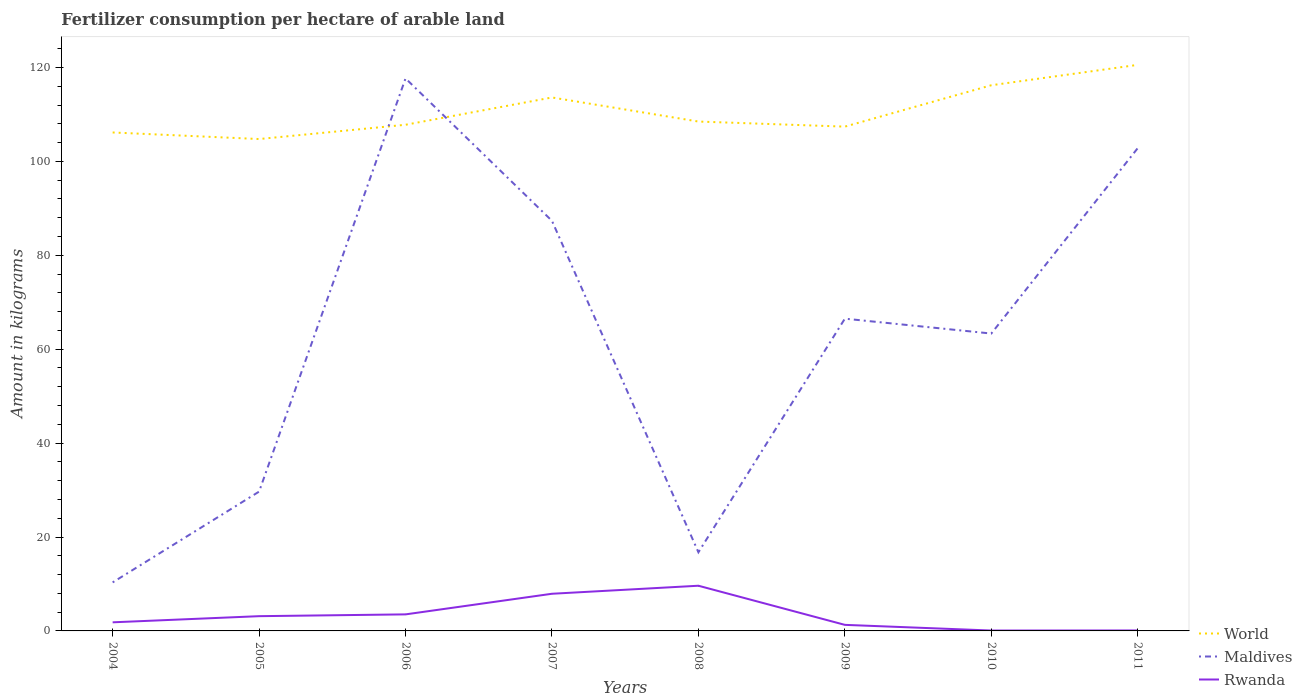Does the line corresponding to World intersect with the line corresponding to Maldives?
Your response must be concise. Yes. Is the number of lines equal to the number of legend labels?
Provide a short and direct response. Yes. Across all years, what is the maximum amount of fertilizer consumption in Rwanda?
Your answer should be compact. 0.08. In which year was the amount of fertilizer consumption in Rwanda maximum?
Provide a short and direct response. 2010. What is the total amount of fertilizer consumption in Rwanda in the graph?
Your answer should be very brief. -1.71. What is the difference between the highest and the second highest amount of fertilizer consumption in Maldives?
Provide a short and direct response. 107.33. Is the amount of fertilizer consumption in World strictly greater than the amount of fertilizer consumption in Maldives over the years?
Give a very brief answer. No. How many lines are there?
Give a very brief answer. 3. Does the graph contain any zero values?
Ensure brevity in your answer.  No. Does the graph contain grids?
Your answer should be very brief. No. Where does the legend appear in the graph?
Ensure brevity in your answer.  Bottom right. How many legend labels are there?
Provide a short and direct response. 3. What is the title of the graph?
Keep it short and to the point. Fertilizer consumption per hectare of arable land. What is the label or title of the X-axis?
Your response must be concise. Years. What is the label or title of the Y-axis?
Your answer should be compact. Amount in kilograms. What is the Amount in kilograms in World in 2004?
Ensure brevity in your answer.  106.15. What is the Amount in kilograms in Maldives in 2004?
Your answer should be very brief. 10.33. What is the Amount in kilograms of Rwanda in 2004?
Offer a terse response. 1.83. What is the Amount in kilograms of World in 2005?
Your answer should be compact. 104.76. What is the Amount in kilograms of Maldives in 2005?
Your response must be concise. 29.67. What is the Amount in kilograms of Rwanda in 2005?
Offer a terse response. 3.14. What is the Amount in kilograms of World in 2006?
Offer a very short reply. 107.79. What is the Amount in kilograms of Maldives in 2006?
Offer a terse response. 117.67. What is the Amount in kilograms of Rwanda in 2006?
Your response must be concise. 3.52. What is the Amount in kilograms in World in 2007?
Give a very brief answer. 113.61. What is the Amount in kilograms of Maldives in 2007?
Ensure brevity in your answer.  87.33. What is the Amount in kilograms in Rwanda in 2007?
Make the answer very short. 7.91. What is the Amount in kilograms of World in 2008?
Provide a short and direct response. 108.48. What is the Amount in kilograms in Maldives in 2008?
Your answer should be very brief. 16.75. What is the Amount in kilograms of Rwanda in 2008?
Your answer should be very brief. 9.62. What is the Amount in kilograms of World in 2009?
Provide a short and direct response. 107.4. What is the Amount in kilograms in Maldives in 2009?
Offer a very short reply. 66.5. What is the Amount in kilograms of Rwanda in 2009?
Your response must be concise. 1.29. What is the Amount in kilograms of World in 2010?
Make the answer very short. 116.21. What is the Amount in kilograms of Maldives in 2010?
Offer a terse response. 63.33. What is the Amount in kilograms in Rwanda in 2010?
Ensure brevity in your answer.  0.08. What is the Amount in kilograms of World in 2011?
Provide a succinct answer. 120.55. What is the Amount in kilograms in Maldives in 2011?
Your answer should be compact. 102.82. What is the Amount in kilograms in Rwanda in 2011?
Your answer should be very brief. 0.1. Across all years, what is the maximum Amount in kilograms in World?
Your response must be concise. 120.55. Across all years, what is the maximum Amount in kilograms of Maldives?
Offer a very short reply. 117.67. Across all years, what is the maximum Amount in kilograms in Rwanda?
Provide a short and direct response. 9.62. Across all years, what is the minimum Amount in kilograms of World?
Provide a succinct answer. 104.76. Across all years, what is the minimum Amount in kilograms of Maldives?
Give a very brief answer. 10.33. Across all years, what is the minimum Amount in kilograms in Rwanda?
Offer a very short reply. 0.08. What is the total Amount in kilograms of World in the graph?
Make the answer very short. 884.96. What is the total Amount in kilograms of Maldives in the graph?
Provide a succinct answer. 494.4. What is the total Amount in kilograms of Rwanda in the graph?
Give a very brief answer. 27.51. What is the difference between the Amount in kilograms in World in 2004 and that in 2005?
Your answer should be very brief. 1.4. What is the difference between the Amount in kilograms of Maldives in 2004 and that in 2005?
Give a very brief answer. -19.33. What is the difference between the Amount in kilograms in Rwanda in 2004 and that in 2005?
Keep it short and to the point. -1.31. What is the difference between the Amount in kilograms of World in 2004 and that in 2006?
Your answer should be compact. -1.64. What is the difference between the Amount in kilograms of Maldives in 2004 and that in 2006?
Your answer should be compact. -107.33. What is the difference between the Amount in kilograms of Rwanda in 2004 and that in 2006?
Provide a succinct answer. -1.69. What is the difference between the Amount in kilograms in World in 2004 and that in 2007?
Keep it short and to the point. -7.45. What is the difference between the Amount in kilograms of Maldives in 2004 and that in 2007?
Provide a succinct answer. -77. What is the difference between the Amount in kilograms in Rwanda in 2004 and that in 2007?
Give a very brief answer. -6.08. What is the difference between the Amount in kilograms of World in 2004 and that in 2008?
Offer a terse response. -2.33. What is the difference between the Amount in kilograms in Maldives in 2004 and that in 2008?
Provide a short and direct response. -6.42. What is the difference between the Amount in kilograms of Rwanda in 2004 and that in 2008?
Keep it short and to the point. -7.79. What is the difference between the Amount in kilograms of World in 2004 and that in 2009?
Your response must be concise. -1.24. What is the difference between the Amount in kilograms in Maldives in 2004 and that in 2009?
Make the answer very short. -56.17. What is the difference between the Amount in kilograms in Rwanda in 2004 and that in 2009?
Your answer should be compact. 0.54. What is the difference between the Amount in kilograms in World in 2004 and that in 2010?
Offer a terse response. -10.06. What is the difference between the Amount in kilograms of Maldives in 2004 and that in 2010?
Your answer should be compact. -53. What is the difference between the Amount in kilograms of Rwanda in 2004 and that in 2010?
Offer a very short reply. 1.75. What is the difference between the Amount in kilograms of World in 2004 and that in 2011?
Provide a succinct answer. -14.4. What is the difference between the Amount in kilograms of Maldives in 2004 and that in 2011?
Make the answer very short. -92.49. What is the difference between the Amount in kilograms of Rwanda in 2004 and that in 2011?
Provide a short and direct response. 1.73. What is the difference between the Amount in kilograms in World in 2005 and that in 2006?
Provide a succinct answer. -3.04. What is the difference between the Amount in kilograms in Maldives in 2005 and that in 2006?
Your answer should be compact. -88. What is the difference between the Amount in kilograms in Rwanda in 2005 and that in 2006?
Make the answer very short. -0.38. What is the difference between the Amount in kilograms of World in 2005 and that in 2007?
Make the answer very short. -8.85. What is the difference between the Amount in kilograms in Maldives in 2005 and that in 2007?
Provide a short and direct response. -57.67. What is the difference between the Amount in kilograms in Rwanda in 2005 and that in 2007?
Offer a terse response. -4.78. What is the difference between the Amount in kilograms of World in 2005 and that in 2008?
Provide a short and direct response. -3.73. What is the difference between the Amount in kilograms of Maldives in 2005 and that in 2008?
Give a very brief answer. 12.92. What is the difference between the Amount in kilograms in Rwanda in 2005 and that in 2008?
Provide a short and direct response. -6.48. What is the difference between the Amount in kilograms in World in 2005 and that in 2009?
Offer a very short reply. -2.64. What is the difference between the Amount in kilograms in Maldives in 2005 and that in 2009?
Ensure brevity in your answer.  -36.83. What is the difference between the Amount in kilograms in Rwanda in 2005 and that in 2009?
Your response must be concise. 1.85. What is the difference between the Amount in kilograms in World in 2005 and that in 2010?
Give a very brief answer. -11.46. What is the difference between the Amount in kilograms of Maldives in 2005 and that in 2010?
Offer a very short reply. -33.67. What is the difference between the Amount in kilograms in Rwanda in 2005 and that in 2010?
Your response must be concise. 3.06. What is the difference between the Amount in kilograms of World in 2005 and that in 2011?
Your response must be concise. -15.8. What is the difference between the Amount in kilograms of Maldives in 2005 and that in 2011?
Your answer should be compact. -73.15. What is the difference between the Amount in kilograms of Rwanda in 2005 and that in 2011?
Provide a succinct answer. 3.04. What is the difference between the Amount in kilograms of World in 2006 and that in 2007?
Make the answer very short. -5.81. What is the difference between the Amount in kilograms of Maldives in 2006 and that in 2007?
Ensure brevity in your answer.  30.33. What is the difference between the Amount in kilograms of Rwanda in 2006 and that in 2007?
Provide a succinct answer. -4.39. What is the difference between the Amount in kilograms in World in 2006 and that in 2008?
Offer a very short reply. -0.69. What is the difference between the Amount in kilograms of Maldives in 2006 and that in 2008?
Your answer should be very brief. 100.92. What is the difference between the Amount in kilograms of Rwanda in 2006 and that in 2008?
Make the answer very short. -6.1. What is the difference between the Amount in kilograms of World in 2006 and that in 2009?
Your response must be concise. 0.4. What is the difference between the Amount in kilograms in Maldives in 2006 and that in 2009?
Provide a succinct answer. 51.17. What is the difference between the Amount in kilograms in Rwanda in 2006 and that in 2009?
Your answer should be very brief. 2.23. What is the difference between the Amount in kilograms of World in 2006 and that in 2010?
Keep it short and to the point. -8.42. What is the difference between the Amount in kilograms of Maldives in 2006 and that in 2010?
Provide a succinct answer. 54.33. What is the difference between the Amount in kilograms in Rwanda in 2006 and that in 2010?
Keep it short and to the point. 3.44. What is the difference between the Amount in kilograms of World in 2006 and that in 2011?
Make the answer very short. -12.76. What is the difference between the Amount in kilograms of Maldives in 2006 and that in 2011?
Offer a very short reply. 14.85. What is the difference between the Amount in kilograms in Rwanda in 2006 and that in 2011?
Provide a succinct answer. 3.42. What is the difference between the Amount in kilograms of World in 2007 and that in 2008?
Give a very brief answer. 5.13. What is the difference between the Amount in kilograms of Maldives in 2007 and that in 2008?
Your answer should be very brief. 70.58. What is the difference between the Amount in kilograms of Rwanda in 2007 and that in 2008?
Make the answer very short. -1.71. What is the difference between the Amount in kilograms in World in 2007 and that in 2009?
Your answer should be very brief. 6.21. What is the difference between the Amount in kilograms of Maldives in 2007 and that in 2009?
Your answer should be very brief. 20.83. What is the difference between the Amount in kilograms of Rwanda in 2007 and that in 2009?
Your answer should be compact. 6.62. What is the difference between the Amount in kilograms of World in 2007 and that in 2010?
Make the answer very short. -2.6. What is the difference between the Amount in kilograms in Maldives in 2007 and that in 2010?
Ensure brevity in your answer.  24. What is the difference between the Amount in kilograms in Rwanda in 2007 and that in 2010?
Your answer should be very brief. 7.83. What is the difference between the Amount in kilograms of World in 2007 and that in 2011?
Give a very brief answer. -6.95. What is the difference between the Amount in kilograms of Maldives in 2007 and that in 2011?
Keep it short and to the point. -15.49. What is the difference between the Amount in kilograms in Rwanda in 2007 and that in 2011?
Provide a short and direct response. 7.81. What is the difference between the Amount in kilograms in World in 2008 and that in 2009?
Give a very brief answer. 1.08. What is the difference between the Amount in kilograms of Maldives in 2008 and that in 2009?
Your response must be concise. -49.75. What is the difference between the Amount in kilograms in Rwanda in 2008 and that in 2009?
Your response must be concise. 8.33. What is the difference between the Amount in kilograms in World in 2008 and that in 2010?
Make the answer very short. -7.73. What is the difference between the Amount in kilograms of Maldives in 2008 and that in 2010?
Provide a succinct answer. -46.58. What is the difference between the Amount in kilograms of Rwanda in 2008 and that in 2010?
Provide a short and direct response. 9.54. What is the difference between the Amount in kilograms of World in 2008 and that in 2011?
Give a very brief answer. -12.07. What is the difference between the Amount in kilograms of Maldives in 2008 and that in 2011?
Your response must be concise. -86.07. What is the difference between the Amount in kilograms in Rwanda in 2008 and that in 2011?
Your answer should be very brief. 9.52. What is the difference between the Amount in kilograms of World in 2009 and that in 2010?
Your response must be concise. -8.81. What is the difference between the Amount in kilograms of Maldives in 2009 and that in 2010?
Your answer should be very brief. 3.17. What is the difference between the Amount in kilograms in Rwanda in 2009 and that in 2010?
Ensure brevity in your answer.  1.21. What is the difference between the Amount in kilograms of World in 2009 and that in 2011?
Your answer should be compact. -13.16. What is the difference between the Amount in kilograms in Maldives in 2009 and that in 2011?
Provide a succinct answer. -36.32. What is the difference between the Amount in kilograms of Rwanda in 2009 and that in 2011?
Keep it short and to the point. 1.19. What is the difference between the Amount in kilograms of World in 2010 and that in 2011?
Your answer should be very brief. -4.34. What is the difference between the Amount in kilograms of Maldives in 2010 and that in 2011?
Keep it short and to the point. -39.49. What is the difference between the Amount in kilograms in Rwanda in 2010 and that in 2011?
Offer a very short reply. -0.02. What is the difference between the Amount in kilograms of World in 2004 and the Amount in kilograms of Maldives in 2005?
Your response must be concise. 76.49. What is the difference between the Amount in kilograms of World in 2004 and the Amount in kilograms of Rwanda in 2005?
Give a very brief answer. 103.02. What is the difference between the Amount in kilograms in Maldives in 2004 and the Amount in kilograms in Rwanda in 2005?
Provide a succinct answer. 7.19. What is the difference between the Amount in kilograms of World in 2004 and the Amount in kilograms of Maldives in 2006?
Your response must be concise. -11.51. What is the difference between the Amount in kilograms in World in 2004 and the Amount in kilograms in Rwanda in 2006?
Provide a succinct answer. 102.63. What is the difference between the Amount in kilograms of Maldives in 2004 and the Amount in kilograms of Rwanda in 2006?
Give a very brief answer. 6.81. What is the difference between the Amount in kilograms of World in 2004 and the Amount in kilograms of Maldives in 2007?
Your answer should be compact. 18.82. What is the difference between the Amount in kilograms in World in 2004 and the Amount in kilograms in Rwanda in 2007?
Make the answer very short. 98.24. What is the difference between the Amount in kilograms in Maldives in 2004 and the Amount in kilograms in Rwanda in 2007?
Offer a terse response. 2.42. What is the difference between the Amount in kilograms of World in 2004 and the Amount in kilograms of Maldives in 2008?
Keep it short and to the point. 89.4. What is the difference between the Amount in kilograms of World in 2004 and the Amount in kilograms of Rwanda in 2008?
Ensure brevity in your answer.  96.53. What is the difference between the Amount in kilograms in Maldives in 2004 and the Amount in kilograms in Rwanda in 2008?
Provide a short and direct response. 0.71. What is the difference between the Amount in kilograms of World in 2004 and the Amount in kilograms of Maldives in 2009?
Your answer should be compact. 39.65. What is the difference between the Amount in kilograms in World in 2004 and the Amount in kilograms in Rwanda in 2009?
Offer a very short reply. 104.86. What is the difference between the Amount in kilograms in Maldives in 2004 and the Amount in kilograms in Rwanda in 2009?
Your answer should be compact. 9.04. What is the difference between the Amount in kilograms of World in 2004 and the Amount in kilograms of Maldives in 2010?
Make the answer very short. 42.82. What is the difference between the Amount in kilograms of World in 2004 and the Amount in kilograms of Rwanda in 2010?
Your answer should be very brief. 106.07. What is the difference between the Amount in kilograms of Maldives in 2004 and the Amount in kilograms of Rwanda in 2010?
Provide a short and direct response. 10.25. What is the difference between the Amount in kilograms in World in 2004 and the Amount in kilograms in Maldives in 2011?
Make the answer very short. 3.33. What is the difference between the Amount in kilograms of World in 2004 and the Amount in kilograms of Rwanda in 2011?
Your answer should be very brief. 106.05. What is the difference between the Amount in kilograms of Maldives in 2004 and the Amount in kilograms of Rwanda in 2011?
Your answer should be compact. 10.23. What is the difference between the Amount in kilograms of World in 2005 and the Amount in kilograms of Maldives in 2006?
Your response must be concise. -12.91. What is the difference between the Amount in kilograms in World in 2005 and the Amount in kilograms in Rwanda in 2006?
Your answer should be compact. 101.23. What is the difference between the Amount in kilograms of Maldives in 2005 and the Amount in kilograms of Rwanda in 2006?
Give a very brief answer. 26.14. What is the difference between the Amount in kilograms of World in 2005 and the Amount in kilograms of Maldives in 2007?
Ensure brevity in your answer.  17.42. What is the difference between the Amount in kilograms of World in 2005 and the Amount in kilograms of Rwanda in 2007?
Offer a terse response. 96.84. What is the difference between the Amount in kilograms in Maldives in 2005 and the Amount in kilograms in Rwanda in 2007?
Your answer should be compact. 21.75. What is the difference between the Amount in kilograms in World in 2005 and the Amount in kilograms in Maldives in 2008?
Your answer should be very brief. 88.01. What is the difference between the Amount in kilograms in World in 2005 and the Amount in kilograms in Rwanda in 2008?
Keep it short and to the point. 95.13. What is the difference between the Amount in kilograms of Maldives in 2005 and the Amount in kilograms of Rwanda in 2008?
Give a very brief answer. 20.04. What is the difference between the Amount in kilograms of World in 2005 and the Amount in kilograms of Maldives in 2009?
Provide a succinct answer. 38.26. What is the difference between the Amount in kilograms in World in 2005 and the Amount in kilograms in Rwanda in 2009?
Provide a short and direct response. 103.46. What is the difference between the Amount in kilograms in Maldives in 2005 and the Amount in kilograms in Rwanda in 2009?
Your answer should be compact. 28.38. What is the difference between the Amount in kilograms in World in 2005 and the Amount in kilograms in Maldives in 2010?
Keep it short and to the point. 41.42. What is the difference between the Amount in kilograms of World in 2005 and the Amount in kilograms of Rwanda in 2010?
Provide a short and direct response. 104.67. What is the difference between the Amount in kilograms in Maldives in 2005 and the Amount in kilograms in Rwanda in 2010?
Your response must be concise. 29.58. What is the difference between the Amount in kilograms of World in 2005 and the Amount in kilograms of Maldives in 2011?
Offer a terse response. 1.93. What is the difference between the Amount in kilograms of World in 2005 and the Amount in kilograms of Rwanda in 2011?
Offer a terse response. 104.66. What is the difference between the Amount in kilograms of Maldives in 2005 and the Amount in kilograms of Rwanda in 2011?
Ensure brevity in your answer.  29.57. What is the difference between the Amount in kilograms in World in 2006 and the Amount in kilograms in Maldives in 2007?
Make the answer very short. 20.46. What is the difference between the Amount in kilograms of World in 2006 and the Amount in kilograms of Rwanda in 2007?
Your answer should be very brief. 99.88. What is the difference between the Amount in kilograms of Maldives in 2006 and the Amount in kilograms of Rwanda in 2007?
Offer a terse response. 109.75. What is the difference between the Amount in kilograms in World in 2006 and the Amount in kilograms in Maldives in 2008?
Offer a very short reply. 91.04. What is the difference between the Amount in kilograms in World in 2006 and the Amount in kilograms in Rwanda in 2008?
Offer a very short reply. 98.17. What is the difference between the Amount in kilograms in Maldives in 2006 and the Amount in kilograms in Rwanda in 2008?
Ensure brevity in your answer.  108.04. What is the difference between the Amount in kilograms in World in 2006 and the Amount in kilograms in Maldives in 2009?
Ensure brevity in your answer.  41.29. What is the difference between the Amount in kilograms of World in 2006 and the Amount in kilograms of Rwanda in 2009?
Give a very brief answer. 106.5. What is the difference between the Amount in kilograms in Maldives in 2006 and the Amount in kilograms in Rwanda in 2009?
Your response must be concise. 116.38. What is the difference between the Amount in kilograms in World in 2006 and the Amount in kilograms in Maldives in 2010?
Give a very brief answer. 44.46. What is the difference between the Amount in kilograms of World in 2006 and the Amount in kilograms of Rwanda in 2010?
Offer a very short reply. 107.71. What is the difference between the Amount in kilograms in Maldives in 2006 and the Amount in kilograms in Rwanda in 2010?
Offer a very short reply. 117.58. What is the difference between the Amount in kilograms of World in 2006 and the Amount in kilograms of Maldives in 2011?
Give a very brief answer. 4.97. What is the difference between the Amount in kilograms of World in 2006 and the Amount in kilograms of Rwanda in 2011?
Give a very brief answer. 107.69. What is the difference between the Amount in kilograms of Maldives in 2006 and the Amount in kilograms of Rwanda in 2011?
Your response must be concise. 117.57. What is the difference between the Amount in kilograms in World in 2007 and the Amount in kilograms in Maldives in 2008?
Your answer should be compact. 96.86. What is the difference between the Amount in kilograms of World in 2007 and the Amount in kilograms of Rwanda in 2008?
Give a very brief answer. 103.99. What is the difference between the Amount in kilograms of Maldives in 2007 and the Amount in kilograms of Rwanda in 2008?
Provide a succinct answer. 77.71. What is the difference between the Amount in kilograms of World in 2007 and the Amount in kilograms of Maldives in 2009?
Keep it short and to the point. 47.11. What is the difference between the Amount in kilograms of World in 2007 and the Amount in kilograms of Rwanda in 2009?
Keep it short and to the point. 112.32. What is the difference between the Amount in kilograms in Maldives in 2007 and the Amount in kilograms in Rwanda in 2009?
Your answer should be compact. 86.04. What is the difference between the Amount in kilograms in World in 2007 and the Amount in kilograms in Maldives in 2010?
Your answer should be very brief. 50.28. What is the difference between the Amount in kilograms in World in 2007 and the Amount in kilograms in Rwanda in 2010?
Your answer should be very brief. 113.52. What is the difference between the Amount in kilograms in Maldives in 2007 and the Amount in kilograms in Rwanda in 2010?
Offer a terse response. 87.25. What is the difference between the Amount in kilograms in World in 2007 and the Amount in kilograms in Maldives in 2011?
Offer a terse response. 10.79. What is the difference between the Amount in kilograms of World in 2007 and the Amount in kilograms of Rwanda in 2011?
Give a very brief answer. 113.51. What is the difference between the Amount in kilograms of Maldives in 2007 and the Amount in kilograms of Rwanda in 2011?
Provide a short and direct response. 87.23. What is the difference between the Amount in kilograms in World in 2008 and the Amount in kilograms in Maldives in 2009?
Provide a short and direct response. 41.98. What is the difference between the Amount in kilograms in World in 2008 and the Amount in kilograms in Rwanda in 2009?
Provide a succinct answer. 107.19. What is the difference between the Amount in kilograms of Maldives in 2008 and the Amount in kilograms of Rwanda in 2009?
Provide a short and direct response. 15.46. What is the difference between the Amount in kilograms of World in 2008 and the Amount in kilograms of Maldives in 2010?
Provide a succinct answer. 45.15. What is the difference between the Amount in kilograms in World in 2008 and the Amount in kilograms in Rwanda in 2010?
Make the answer very short. 108.4. What is the difference between the Amount in kilograms in Maldives in 2008 and the Amount in kilograms in Rwanda in 2010?
Your answer should be compact. 16.67. What is the difference between the Amount in kilograms of World in 2008 and the Amount in kilograms of Maldives in 2011?
Offer a terse response. 5.66. What is the difference between the Amount in kilograms of World in 2008 and the Amount in kilograms of Rwanda in 2011?
Your answer should be very brief. 108.38. What is the difference between the Amount in kilograms in Maldives in 2008 and the Amount in kilograms in Rwanda in 2011?
Provide a succinct answer. 16.65. What is the difference between the Amount in kilograms of World in 2009 and the Amount in kilograms of Maldives in 2010?
Offer a very short reply. 44.06. What is the difference between the Amount in kilograms of World in 2009 and the Amount in kilograms of Rwanda in 2010?
Offer a very short reply. 107.31. What is the difference between the Amount in kilograms of Maldives in 2009 and the Amount in kilograms of Rwanda in 2010?
Provide a short and direct response. 66.42. What is the difference between the Amount in kilograms in World in 2009 and the Amount in kilograms in Maldives in 2011?
Keep it short and to the point. 4.58. What is the difference between the Amount in kilograms of World in 2009 and the Amount in kilograms of Rwanda in 2011?
Your response must be concise. 107.3. What is the difference between the Amount in kilograms of Maldives in 2009 and the Amount in kilograms of Rwanda in 2011?
Your answer should be compact. 66.4. What is the difference between the Amount in kilograms of World in 2010 and the Amount in kilograms of Maldives in 2011?
Provide a short and direct response. 13.39. What is the difference between the Amount in kilograms of World in 2010 and the Amount in kilograms of Rwanda in 2011?
Keep it short and to the point. 116.11. What is the difference between the Amount in kilograms of Maldives in 2010 and the Amount in kilograms of Rwanda in 2011?
Give a very brief answer. 63.23. What is the average Amount in kilograms in World per year?
Offer a very short reply. 110.62. What is the average Amount in kilograms of Maldives per year?
Provide a succinct answer. 61.8. What is the average Amount in kilograms of Rwanda per year?
Offer a very short reply. 3.44. In the year 2004, what is the difference between the Amount in kilograms in World and Amount in kilograms in Maldives?
Your response must be concise. 95.82. In the year 2004, what is the difference between the Amount in kilograms of World and Amount in kilograms of Rwanda?
Your answer should be very brief. 104.32. In the year 2004, what is the difference between the Amount in kilograms in Maldives and Amount in kilograms in Rwanda?
Offer a terse response. 8.5. In the year 2005, what is the difference between the Amount in kilograms of World and Amount in kilograms of Maldives?
Ensure brevity in your answer.  75.09. In the year 2005, what is the difference between the Amount in kilograms in World and Amount in kilograms in Rwanda?
Your answer should be compact. 101.62. In the year 2005, what is the difference between the Amount in kilograms of Maldives and Amount in kilograms of Rwanda?
Make the answer very short. 26.53. In the year 2006, what is the difference between the Amount in kilograms of World and Amount in kilograms of Maldives?
Your answer should be compact. -9.87. In the year 2006, what is the difference between the Amount in kilograms in World and Amount in kilograms in Rwanda?
Offer a very short reply. 104.27. In the year 2006, what is the difference between the Amount in kilograms in Maldives and Amount in kilograms in Rwanda?
Give a very brief answer. 114.14. In the year 2007, what is the difference between the Amount in kilograms in World and Amount in kilograms in Maldives?
Ensure brevity in your answer.  26.28. In the year 2007, what is the difference between the Amount in kilograms in World and Amount in kilograms in Rwanda?
Your response must be concise. 105.69. In the year 2007, what is the difference between the Amount in kilograms of Maldives and Amount in kilograms of Rwanda?
Your answer should be very brief. 79.42. In the year 2008, what is the difference between the Amount in kilograms in World and Amount in kilograms in Maldives?
Ensure brevity in your answer.  91.73. In the year 2008, what is the difference between the Amount in kilograms of World and Amount in kilograms of Rwanda?
Offer a very short reply. 98.86. In the year 2008, what is the difference between the Amount in kilograms in Maldives and Amount in kilograms in Rwanda?
Provide a short and direct response. 7.13. In the year 2009, what is the difference between the Amount in kilograms in World and Amount in kilograms in Maldives?
Provide a short and direct response. 40.9. In the year 2009, what is the difference between the Amount in kilograms in World and Amount in kilograms in Rwanda?
Ensure brevity in your answer.  106.11. In the year 2009, what is the difference between the Amount in kilograms in Maldives and Amount in kilograms in Rwanda?
Provide a short and direct response. 65.21. In the year 2010, what is the difference between the Amount in kilograms in World and Amount in kilograms in Maldives?
Ensure brevity in your answer.  52.88. In the year 2010, what is the difference between the Amount in kilograms in World and Amount in kilograms in Rwanda?
Make the answer very short. 116.13. In the year 2010, what is the difference between the Amount in kilograms of Maldives and Amount in kilograms of Rwanda?
Your response must be concise. 63.25. In the year 2011, what is the difference between the Amount in kilograms in World and Amount in kilograms in Maldives?
Give a very brief answer. 17.73. In the year 2011, what is the difference between the Amount in kilograms of World and Amount in kilograms of Rwanda?
Offer a very short reply. 120.45. In the year 2011, what is the difference between the Amount in kilograms of Maldives and Amount in kilograms of Rwanda?
Provide a short and direct response. 102.72. What is the ratio of the Amount in kilograms in World in 2004 to that in 2005?
Keep it short and to the point. 1.01. What is the ratio of the Amount in kilograms of Maldives in 2004 to that in 2005?
Give a very brief answer. 0.35. What is the ratio of the Amount in kilograms of Rwanda in 2004 to that in 2005?
Make the answer very short. 0.58. What is the ratio of the Amount in kilograms of Maldives in 2004 to that in 2006?
Your answer should be compact. 0.09. What is the ratio of the Amount in kilograms in Rwanda in 2004 to that in 2006?
Provide a succinct answer. 0.52. What is the ratio of the Amount in kilograms of World in 2004 to that in 2007?
Offer a terse response. 0.93. What is the ratio of the Amount in kilograms of Maldives in 2004 to that in 2007?
Give a very brief answer. 0.12. What is the ratio of the Amount in kilograms in Rwanda in 2004 to that in 2007?
Keep it short and to the point. 0.23. What is the ratio of the Amount in kilograms in World in 2004 to that in 2008?
Your answer should be very brief. 0.98. What is the ratio of the Amount in kilograms in Maldives in 2004 to that in 2008?
Give a very brief answer. 0.62. What is the ratio of the Amount in kilograms of Rwanda in 2004 to that in 2008?
Provide a short and direct response. 0.19. What is the ratio of the Amount in kilograms of World in 2004 to that in 2009?
Keep it short and to the point. 0.99. What is the ratio of the Amount in kilograms of Maldives in 2004 to that in 2009?
Ensure brevity in your answer.  0.16. What is the ratio of the Amount in kilograms of Rwanda in 2004 to that in 2009?
Your response must be concise. 1.42. What is the ratio of the Amount in kilograms in World in 2004 to that in 2010?
Provide a succinct answer. 0.91. What is the ratio of the Amount in kilograms in Maldives in 2004 to that in 2010?
Keep it short and to the point. 0.16. What is the ratio of the Amount in kilograms of Rwanda in 2004 to that in 2010?
Your response must be concise. 21.9. What is the ratio of the Amount in kilograms of World in 2004 to that in 2011?
Offer a very short reply. 0.88. What is the ratio of the Amount in kilograms of Maldives in 2004 to that in 2011?
Ensure brevity in your answer.  0.1. What is the ratio of the Amount in kilograms in Rwanda in 2004 to that in 2011?
Provide a short and direct response. 18.34. What is the ratio of the Amount in kilograms in World in 2005 to that in 2006?
Offer a terse response. 0.97. What is the ratio of the Amount in kilograms in Maldives in 2005 to that in 2006?
Make the answer very short. 0.25. What is the ratio of the Amount in kilograms of Rwanda in 2005 to that in 2006?
Keep it short and to the point. 0.89. What is the ratio of the Amount in kilograms in World in 2005 to that in 2007?
Provide a succinct answer. 0.92. What is the ratio of the Amount in kilograms in Maldives in 2005 to that in 2007?
Your answer should be very brief. 0.34. What is the ratio of the Amount in kilograms in Rwanda in 2005 to that in 2007?
Your response must be concise. 0.4. What is the ratio of the Amount in kilograms in World in 2005 to that in 2008?
Offer a very short reply. 0.97. What is the ratio of the Amount in kilograms of Maldives in 2005 to that in 2008?
Give a very brief answer. 1.77. What is the ratio of the Amount in kilograms in Rwanda in 2005 to that in 2008?
Your answer should be very brief. 0.33. What is the ratio of the Amount in kilograms of World in 2005 to that in 2009?
Provide a short and direct response. 0.98. What is the ratio of the Amount in kilograms of Maldives in 2005 to that in 2009?
Your answer should be very brief. 0.45. What is the ratio of the Amount in kilograms in Rwanda in 2005 to that in 2009?
Ensure brevity in your answer.  2.43. What is the ratio of the Amount in kilograms in World in 2005 to that in 2010?
Your response must be concise. 0.9. What is the ratio of the Amount in kilograms in Maldives in 2005 to that in 2010?
Make the answer very short. 0.47. What is the ratio of the Amount in kilograms of Rwanda in 2005 to that in 2010?
Your answer should be very brief. 37.54. What is the ratio of the Amount in kilograms of World in 2005 to that in 2011?
Your answer should be compact. 0.87. What is the ratio of the Amount in kilograms of Maldives in 2005 to that in 2011?
Your answer should be very brief. 0.29. What is the ratio of the Amount in kilograms in Rwanda in 2005 to that in 2011?
Your answer should be very brief. 31.44. What is the ratio of the Amount in kilograms of World in 2006 to that in 2007?
Ensure brevity in your answer.  0.95. What is the ratio of the Amount in kilograms in Maldives in 2006 to that in 2007?
Keep it short and to the point. 1.35. What is the ratio of the Amount in kilograms of Rwanda in 2006 to that in 2007?
Your answer should be very brief. 0.45. What is the ratio of the Amount in kilograms in World in 2006 to that in 2008?
Provide a succinct answer. 0.99. What is the ratio of the Amount in kilograms of Maldives in 2006 to that in 2008?
Ensure brevity in your answer.  7.02. What is the ratio of the Amount in kilograms of Rwanda in 2006 to that in 2008?
Your answer should be very brief. 0.37. What is the ratio of the Amount in kilograms in World in 2006 to that in 2009?
Your answer should be compact. 1. What is the ratio of the Amount in kilograms of Maldives in 2006 to that in 2009?
Your answer should be compact. 1.77. What is the ratio of the Amount in kilograms of Rwanda in 2006 to that in 2009?
Offer a terse response. 2.73. What is the ratio of the Amount in kilograms of World in 2006 to that in 2010?
Your answer should be very brief. 0.93. What is the ratio of the Amount in kilograms of Maldives in 2006 to that in 2010?
Offer a very short reply. 1.86. What is the ratio of the Amount in kilograms of Rwanda in 2006 to that in 2010?
Give a very brief answer. 42.13. What is the ratio of the Amount in kilograms in World in 2006 to that in 2011?
Your answer should be very brief. 0.89. What is the ratio of the Amount in kilograms of Maldives in 2006 to that in 2011?
Keep it short and to the point. 1.14. What is the ratio of the Amount in kilograms in Rwanda in 2006 to that in 2011?
Offer a terse response. 35.28. What is the ratio of the Amount in kilograms of World in 2007 to that in 2008?
Provide a succinct answer. 1.05. What is the ratio of the Amount in kilograms in Maldives in 2007 to that in 2008?
Your answer should be very brief. 5.21. What is the ratio of the Amount in kilograms of Rwanda in 2007 to that in 2008?
Your answer should be compact. 0.82. What is the ratio of the Amount in kilograms of World in 2007 to that in 2009?
Provide a succinct answer. 1.06. What is the ratio of the Amount in kilograms of Maldives in 2007 to that in 2009?
Make the answer very short. 1.31. What is the ratio of the Amount in kilograms of Rwanda in 2007 to that in 2009?
Make the answer very short. 6.13. What is the ratio of the Amount in kilograms of World in 2007 to that in 2010?
Provide a short and direct response. 0.98. What is the ratio of the Amount in kilograms in Maldives in 2007 to that in 2010?
Offer a very short reply. 1.38. What is the ratio of the Amount in kilograms in Rwanda in 2007 to that in 2010?
Provide a succinct answer. 94.63. What is the ratio of the Amount in kilograms in World in 2007 to that in 2011?
Your answer should be compact. 0.94. What is the ratio of the Amount in kilograms in Maldives in 2007 to that in 2011?
Ensure brevity in your answer.  0.85. What is the ratio of the Amount in kilograms in Rwanda in 2007 to that in 2011?
Provide a short and direct response. 79.25. What is the ratio of the Amount in kilograms in World in 2008 to that in 2009?
Offer a terse response. 1.01. What is the ratio of the Amount in kilograms of Maldives in 2008 to that in 2009?
Make the answer very short. 0.25. What is the ratio of the Amount in kilograms of Rwanda in 2008 to that in 2009?
Offer a terse response. 7.46. What is the ratio of the Amount in kilograms of World in 2008 to that in 2010?
Your response must be concise. 0.93. What is the ratio of the Amount in kilograms of Maldives in 2008 to that in 2010?
Ensure brevity in your answer.  0.26. What is the ratio of the Amount in kilograms in Rwanda in 2008 to that in 2010?
Give a very brief answer. 115.06. What is the ratio of the Amount in kilograms of World in 2008 to that in 2011?
Ensure brevity in your answer.  0.9. What is the ratio of the Amount in kilograms in Maldives in 2008 to that in 2011?
Ensure brevity in your answer.  0.16. What is the ratio of the Amount in kilograms of Rwanda in 2008 to that in 2011?
Give a very brief answer. 96.35. What is the ratio of the Amount in kilograms in World in 2009 to that in 2010?
Ensure brevity in your answer.  0.92. What is the ratio of the Amount in kilograms in Rwanda in 2009 to that in 2010?
Your response must be concise. 15.43. What is the ratio of the Amount in kilograms of World in 2009 to that in 2011?
Keep it short and to the point. 0.89. What is the ratio of the Amount in kilograms of Maldives in 2009 to that in 2011?
Make the answer very short. 0.65. What is the ratio of the Amount in kilograms in Rwanda in 2009 to that in 2011?
Ensure brevity in your answer.  12.92. What is the ratio of the Amount in kilograms of World in 2010 to that in 2011?
Provide a short and direct response. 0.96. What is the ratio of the Amount in kilograms in Maldives in 2010 to that in 2011?
Offer a terse response. 0.62. What is the ratio of the Amount in kilograms of Rwanda in 2010 to that in 2011?
Provide a succinct answer. 0.84. What is the difference between the highest and the second highest Amount in kilograms in World?
Ensure brevity in your answer.  4.34. What is the difference between the highest and the second highest Amount in kilograms of Maldives?
Your response must be concise. 14.85. What is the difference between the highest and the second highest Amount in kilograms in Rwanda?
Your response must be concise. 1.71. What is the difference between the highest and the lowest Amount in kilograms of World?
Your response must be concise. 15.8. What is the difference between the highest and the lowest Amount in kilograms of Maldives?
Offer a terse response. 107.33. What is the difference between the highest and the lowest Amount in kilograms in Rwanda?
Offer a very short reply. 9.54. 